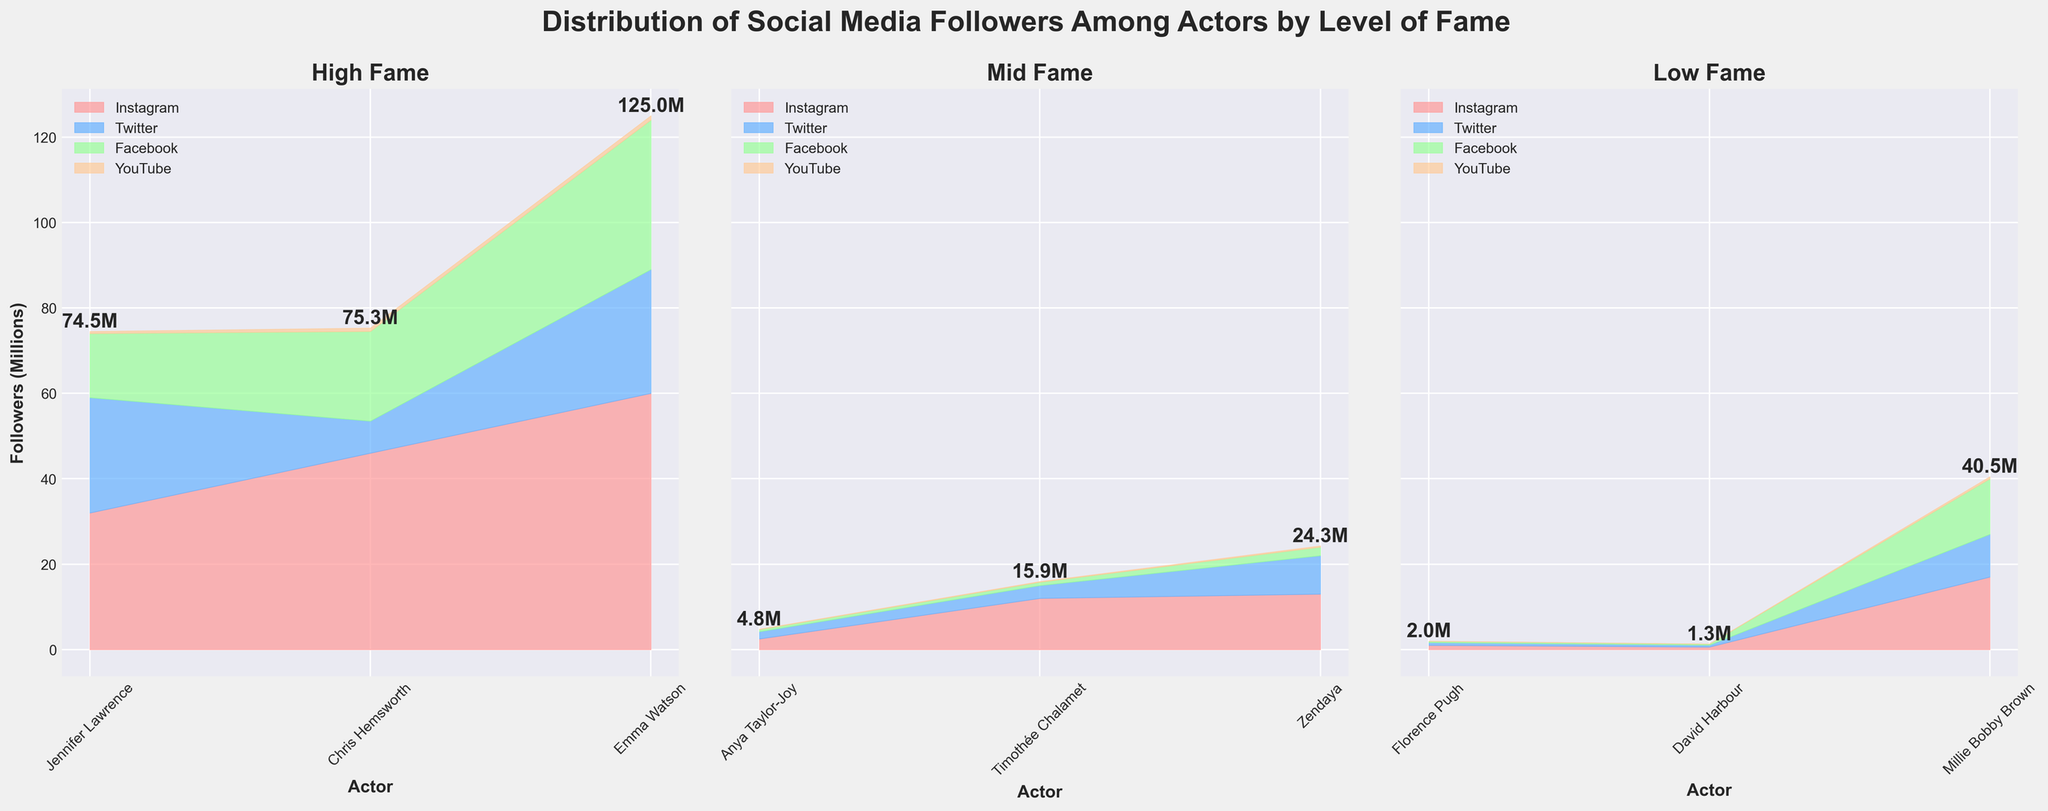What's the title of the plot? The title of the plot is written at the top of the figure in bold text. It provides a summary of what the plot is about.
Answer: Distribution of Social Media Followers Among Actors by Level of Fame What are the three levels of fame represented in the subplots? The subplots are categorized by the level of fame: High, Mid, and Low. These are the titles above each subplot.
Answer: High, Mid, Low Which actor has the highest total number of followers in the 'High Fame' category? By examining the total height of the stacked areas for each actor in the 'High Fame' subplot, it is evident that Emma Watson has the highest total number of followers.
Answer: Emma Watson How many platforms are compared in this plot, and what are their colors? There are four platforms compared in this plot. The colors used for the platforms are visible in the legend.
Answer: Four platforms: Instagram (pink), Twitter (blue), Facebook (green), YouTube (orange) What's the total number of followers for Timothée Chalamet? By summing the heights of the areas corresponding to Timothée Chalamet in the 'Mid Fame' subplot: 12M (Instagram) + 3M (Twitter) + 0.8M (Facebook) + 0.15M (YouTube) = 15.95M.
Answer: 15.95M Which platform does Jennifer Lawrence have the least number of followers on? In the 'High Fame' subplot, for Jennifer Lawrence, the smallest area is for YouTube.
Answer: YouTube Which actor in the 'Low Fame' category has the most significant number of Twitter followers? In the 'Low Fame' subplot, Millie Bobby Brown has the largest area for Twitter.
Answer: Millie Bobby Brown By how much does Emma Watson's Instagram following exceed Chris Hemsworth's Instagram following? Subtract Chris Hemsworth's Instagram followers from Emma Watson's Instagram followers: 60M - 46M = 14M.
Answer: 14M What percentage of Anya Taylor-Joy's total followers come from Instagram? Anya Taylor-Joy's total followers = 2.5M (Instagram) + 1.7M (Twitter) + 0.5M (Facebook) + 0.1M (YouTube) = 4.8M. Percentage from Instagram = (2.5M/4.8M) * 100 ≈ 52.08%.
Answer: 52.08% Compare the total number of followers on Facebook between actors with 'Low Fame' and 'Mid Fame'. Sum the Facebook followers for 'Low Fame': 0.3M + 0.25M + 13M = 13.55M. For 'Mid Fame': 0.5M + 0.8M + 2M = 3.3M. Comparatively, Low Fame actors have more Facebook followers.
Answer: Low Fame has more 